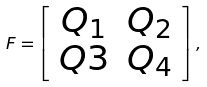Convert formula to latex. <formula><loc_0><loc_0><loc_500><loc_500>F = \left [ \begin{array} { c c } Q _ { 1 } & Q _ { 2 } \\ Q 3 & Q _ { 4 } \end{array} \right ] ,</formula> 